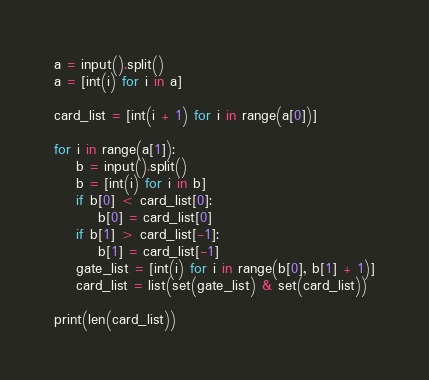<code> <loc_0><loc_0><loc_500><loc_500><_Python_>a = input().split()
a = [int(i) for i in a]

card_list = [int(i + 1) for i in range(a[0])]

for i in range(a[1]):
    b = input().split()
    b = [int(i) for i in b]
    if b[0] < card_list[0]:
        b[0] = card_list[0]
    if b[1] > card_list[-1]:
        b[1] = card_list[-1]
    gate_list = [int(i) for i in range(b[0], b[1] + 1)]
    card_list = list(set(gate_list) & set(card_list))

print(len(card_list))
</code> 